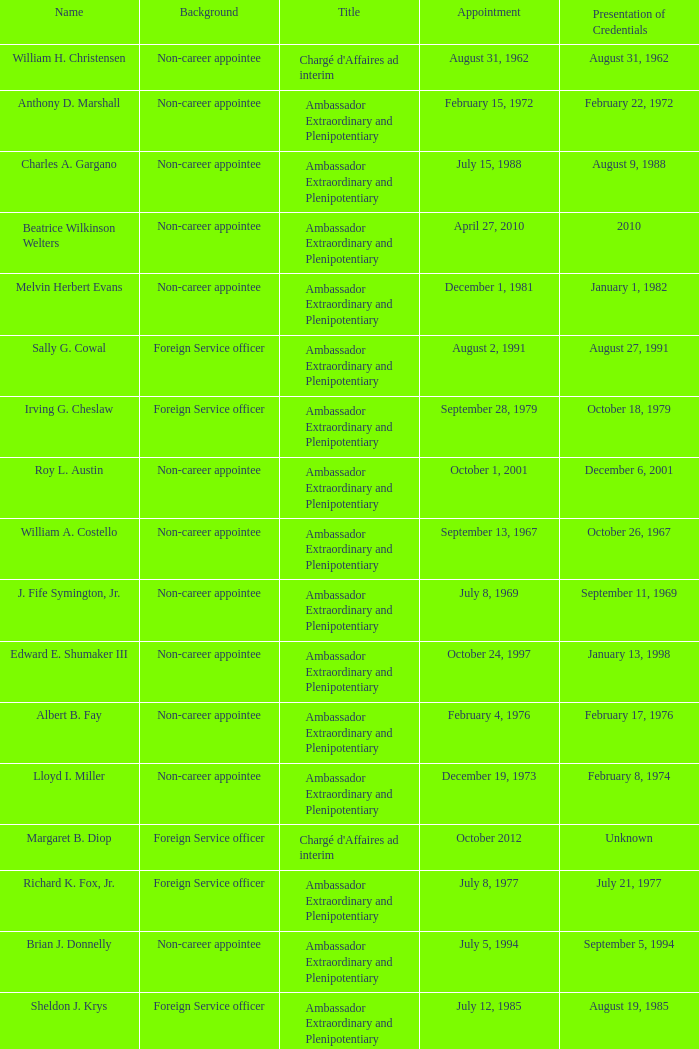Who was appointed on October 24, 1997? Edward E. Shumaker III. 